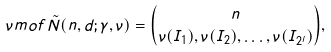<formula> <loc_0><loc_0><loc_500><loc_500>\nu m o f { \tilde { N } ( n , d ; \gamma , \nu ) } & = \binom { n } { \nu ( I _ { 1 } ) , \nu ( I _ { 2 } ) , \dots , \nu ( I _ { 2 ^ { l } } ) } ,</formula> 